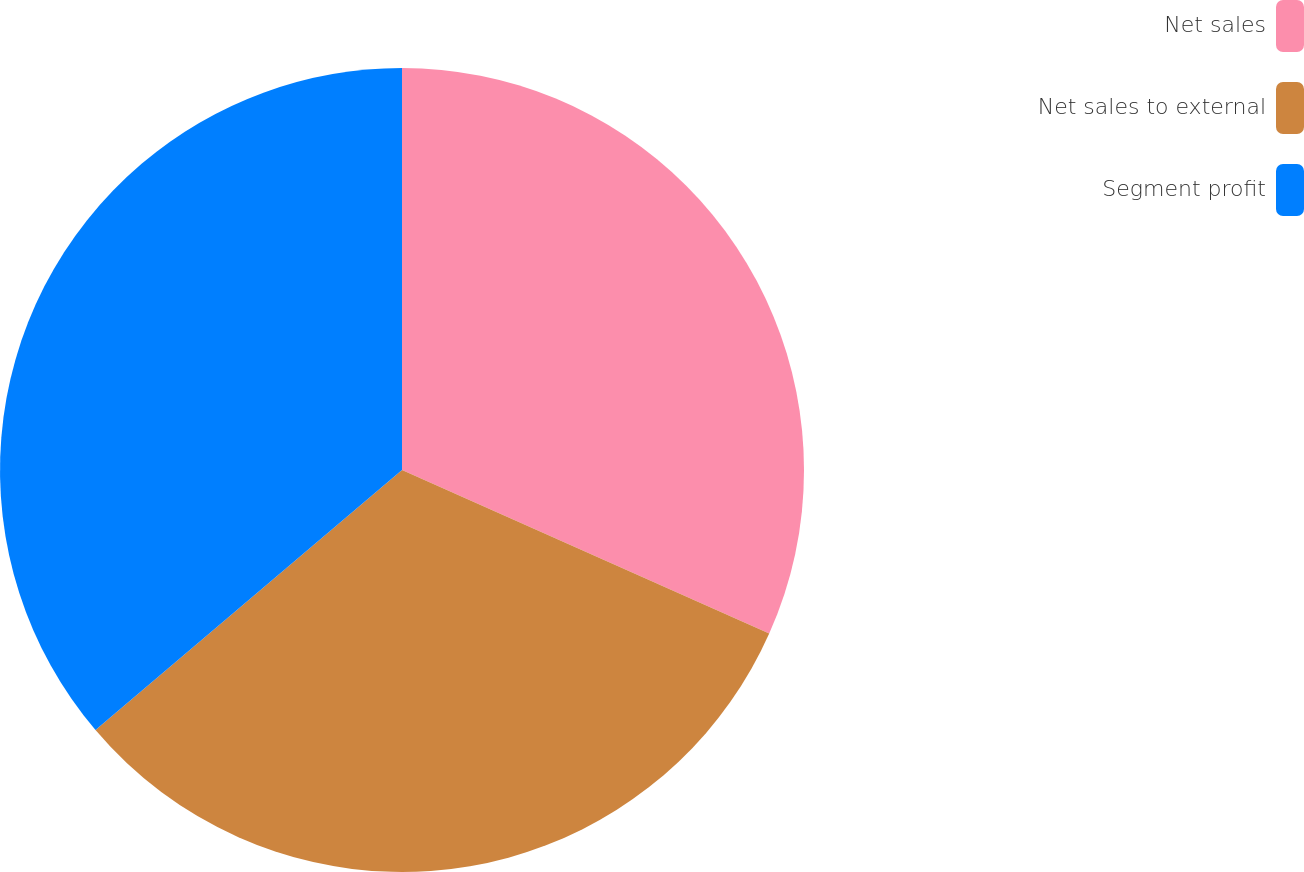<chart> <loc_0><loc_0><loc_500><loc_500><pie_chart><fcel>Net sales<fcel>Net sales to external<fcel>Segment profit<nl><fcel>31.67%<fcel>32.13%<fcel>36.2%<nl></chart> 